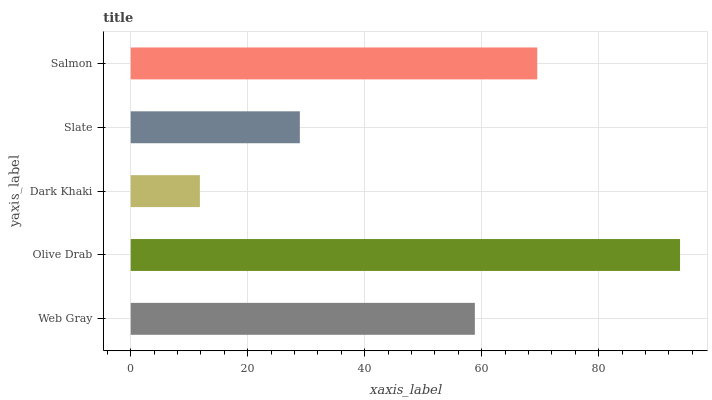Is Dark Khaki the minimum?
Answer yes or no. Yes. Is Olive Drab the maximum?
Answer yes or no. Yes. Is Olive Drab the minimum?
Answer yes or no. No. Is Dark Khaki the maximum?
Answer yes or no. No. Is Olive Drab greater than Dark Khaki?
Answer yes or no. Yes. Is Dark Khaki less than Olive Drab?
Answer yes or no. Yes. Is Dark Khaki greater than Olive Drab?
Answer yes or no. No. Is Olive Drab less than Dark Khaki?
Answer yes or no. No. Is Web Gray the high median?
Answer yes or no. Yes. Is Web Gray the low median?
Answer yes or no. Yes. Is Olive Drab the high median?
Answer yes or no. No. Is Salmon the low median?
Answer yes or no. No. 